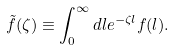<formula> <loc_0><loc_0><loc_500><loc_500>\tilde { f } ( \zeta ) \equiv \int _ { 0 } ^ { \infty } d l e ^ { - \zeta l } f ( l ) .</formula> 